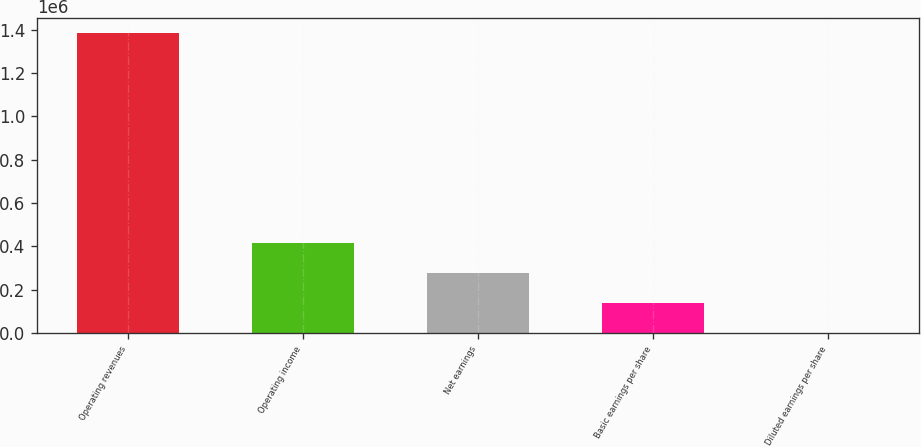Convert chart to OTSL. <chart><loc_0><loc_0><loc_500><loc_500><bar_chart><fcel>Operating revenues<fcel>Operating income<fcel>Net earnings<fcel>Basic earnings per share<fcel>Diluted earnings per share<nl><fcel>1.38286e+06<fcel>414858<fcel>276572<fcel>138286<fcel>0.73<nl></chart> 